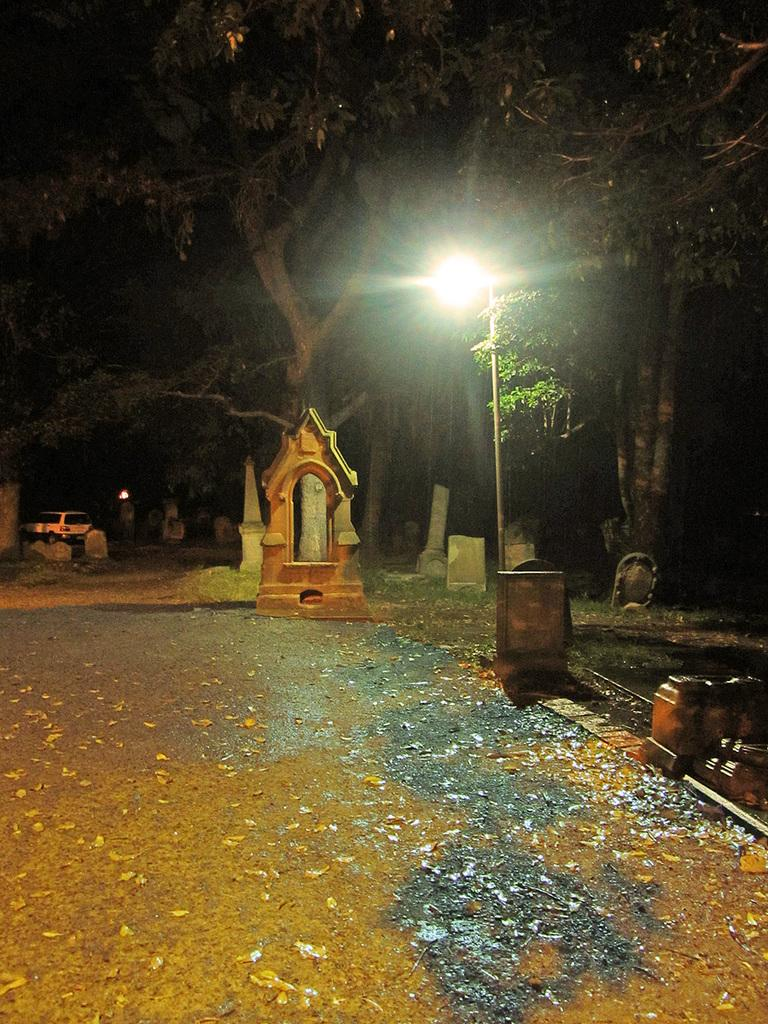What is the main subject in the image? There is a statue in the image. What can be seen on the right side of the image? There is a light pole on the right side of the image. What is visible in the background of the image? There is a group of trees and a vehicle parked on the ground in the background of the image. What type of shoes is the statue wearing in the image? The statue does not have shoes, as it is a sculpture and not a person. 